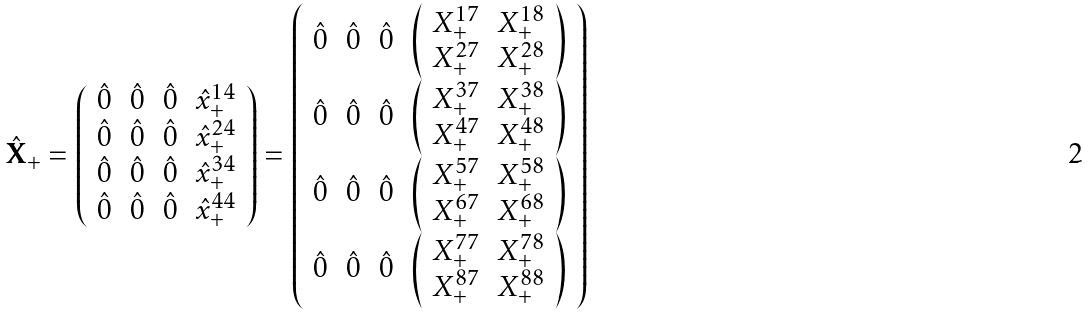Convert formula to latex. <formula><loc_0><loc_0><loc_500><loc_500>\hat { \mathbf X } _ { + } = \left ( \begin{array} { c c c c } \hat { 0 } & \hat { 0 } & \hat { 0 } & \hat { x } _ { + } ^ { 1 4 } \\ \hat { 0 } & \hat { 0 } & \hat { 0 } & \hat { x } _ { + } ^ { 2 4 } \\ \hat { 0 } & \hat { 0 } & \hat { 0 } & \hat { x } _ { + } ^ { 3 4 } \\ \hat { 0 } & \hat { 0 } & \hat { 0 } & \hat { x } _ { + } ^ { 4 4 } \\ \end{array} \right ) = \left ( \begin{array} { c c c c } \hat { 0 } & \hat { 0 } & \hat { 0 } & \left ( \begin{array} { c c } X _ { + } ^ { 1 7 } & X _ { + } ^ { 1 8 } \\ X _ { + } ^ { 2 7 } & X _ { + } ^ { 2 8 } \\ \end{array} \right ) \\ \hat { 0 } & \hat { 0 } & \hat { 0 } & \left ( \begin{array} { c c } X _ { + } ^ { 3 7 } & X _ { + } ^ { 3 8 } \\ X _ { + } ^ { 4 7 } & X _ { + } ^ { 4 8 } \\ \end{array} \right ) \\ \hat { 0 } & \hat { 0 } & \hat { 0 } & \left ( \begin{array} { c c } X _ { + } ^ { 5 7 } & X _ { + } ^ { 5 8 } \\ X _ { + } ^ { 6 7 } & X _ { + } ^ { 6 8 } \\ \end{array} \right ) \\ \hat { 0 } & \hat { 0 } & \hat { 0 } & \left ( \begin{array} { c c } X _ { + } ^ { 7 7 } & X _ { + } ^ { 7 8 } \\ X _ { + } ^ { 8 7 } & X _ { + } ^ { 8 8 } \\ \end{array} \right ) \\ \end{array} \right )</formula> 